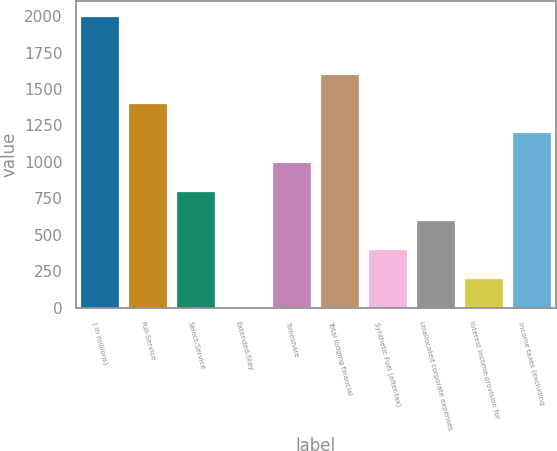Convert chart. <chart><loc_0><loc_0><loc_500><loc_500><bar_chart><fcel>( in millions)<fcel>Full-Service<fcel>Select-Service<fcel>Extended-Stay<fcel>Timeshare<fcel>Total lodging financial<fcel>Synthetic Fuel (after-tax)<fcel>Unallocated corporate expenses<fcel>Interest income provision for<fcel>Income taxes (excluding<nl><fcel>2002<fcel>1402.3<fcel>802.6<fcel>3<fcel>1002.5<fcel>1602.2<fcel>402.8<fcel>602.7<fcel>202.9<fcel>1202.4<nl></chart> 